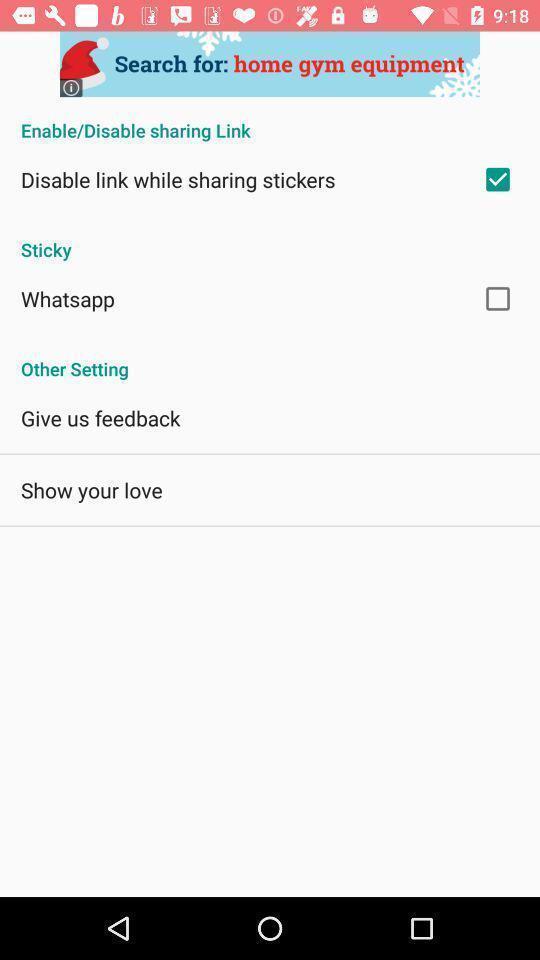Summarize the main components in this picture. Settings page displayed. 